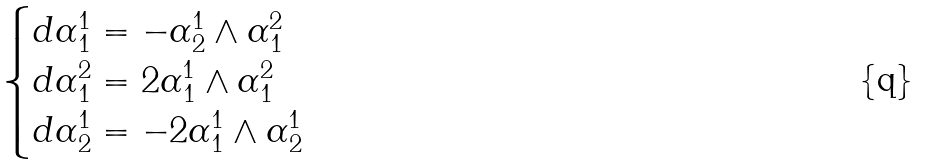<formula> <loc_0><loc_0><loc_500><loc_500>\begin{cases} d \alpha ^ { 1 } _ { 1 } = - \alpha ^ { 1 } _ { 2 } \wedge \alpha ^ { 2 } _ { 1 } \\ d \alpha ^ { 2 } _ { 1 } = 2 \alpha ^ { 1 } _ { 1 } \wedge \alpha ^ { 2 } _ { 1 } \\ d \alpha ^ { 1 } _ { 2 } = - 2 \alpha ^ { 1 } _ { 1 } \wedge \alpha ^ { 1 } _ { 2 } \end{cases}</formula> 